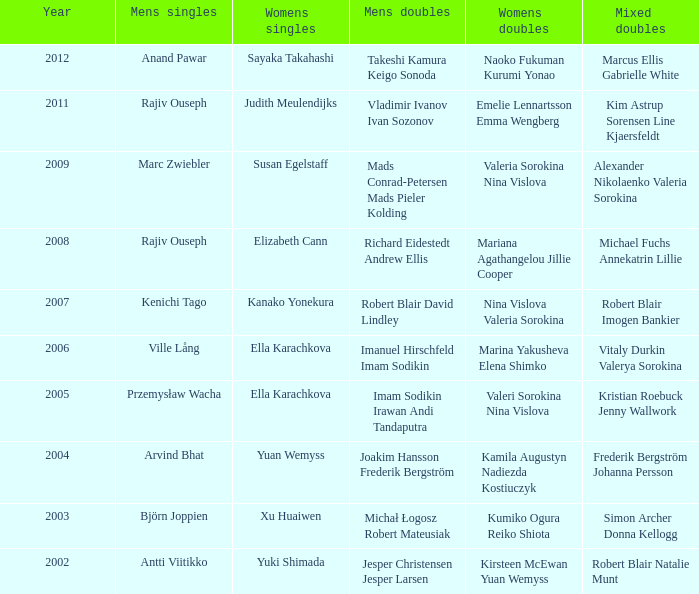Would you be able to parse every entry in this table? {'header': ['Year', 'Mens singles', 'Womens singles', 'Mens doubles', 'Womens doubles', 'Mixed doubles'], 'rows': [['2012', 'Anand Pawar', 'Sayaka Takahashi', 'Takeshi Kamura Keigo Sonoda', 'Naoko Fukuman Kurumi Yonao', 'Marcus Ellis Gabrielle White'], ['2011', 'Rajiv Ouseph', 'Judith Meulendijks', 'Vladimir Ivanov Ivan Sozonov', 'Emelie Lennartsson Emma Wengberg', 'Kim Astrup Sorensen Line Kjaersfeldt'], ['2009', 'Marc Zwiebler', 'Susan Egelstaff', 'Mads Conrad-Petersen Mads Pieler Kolding', 'Valeria Sorokina Nina Vislova', 'Alexander Nikolaenko Valeria Sorokina'], ['2008', 'Rajiv Ouseph', 'Elizabeth Cann', 'Richard Eidestedt Andrew Ellis', 'Mariana Agathangelou Jillie Cooper', 'Michael Fuchs Annekatrin Lillie'], ['2007', 'Kenichi Tago', 'Kanako Yonekura', 'Robert Blair David Lindley', 'Nina Vislova Valeria Sorokina', 'Robert Blair Imogen Bankier'], ['2006', 'Ville Lång', 'Ella Karachkova', 'Imanuel Hirschfeld Imam Sodikin', 'Marina Yakusheva Elena Shimko', 'Vitaly Durkin Valerya Sorokina'], ['2005', 'Przemysław Wacha', 'Ella Karachkova', 'Imam Sodikin Irawan Andi Tandaputra', 'Valeri Sorokina Nina Vislova', 'Kristian Roebuck Jenny Wallwork'], ['2004', 'Arvind Bhat', 'Yuan Wemyss', 'Joakim Hansson Frederik Bergström', 'Kamila Augustyn Nadiezda Kostiuczyk', 'Frederik Bergström Johanna Persson'], ['2003', 'Björn Joppien', 'Xu Huaiwen', 'Michał Łogosz Robert Mateusiak', 'Kumiko Ogura Reiko Shiota', 'Simon Archer Donna Kellogg'], ['2002', 'Antti Viitikko', 'Yuki Shimada', 'Jesper Christensen Jesper Larsen', 'Kirsteen McEwan Yuan Wemyss', 'Robert Blair Natalie Munt']]} What are the womens singles of imam sodikin irawan andi tandaputra? Ella Karachkova. 